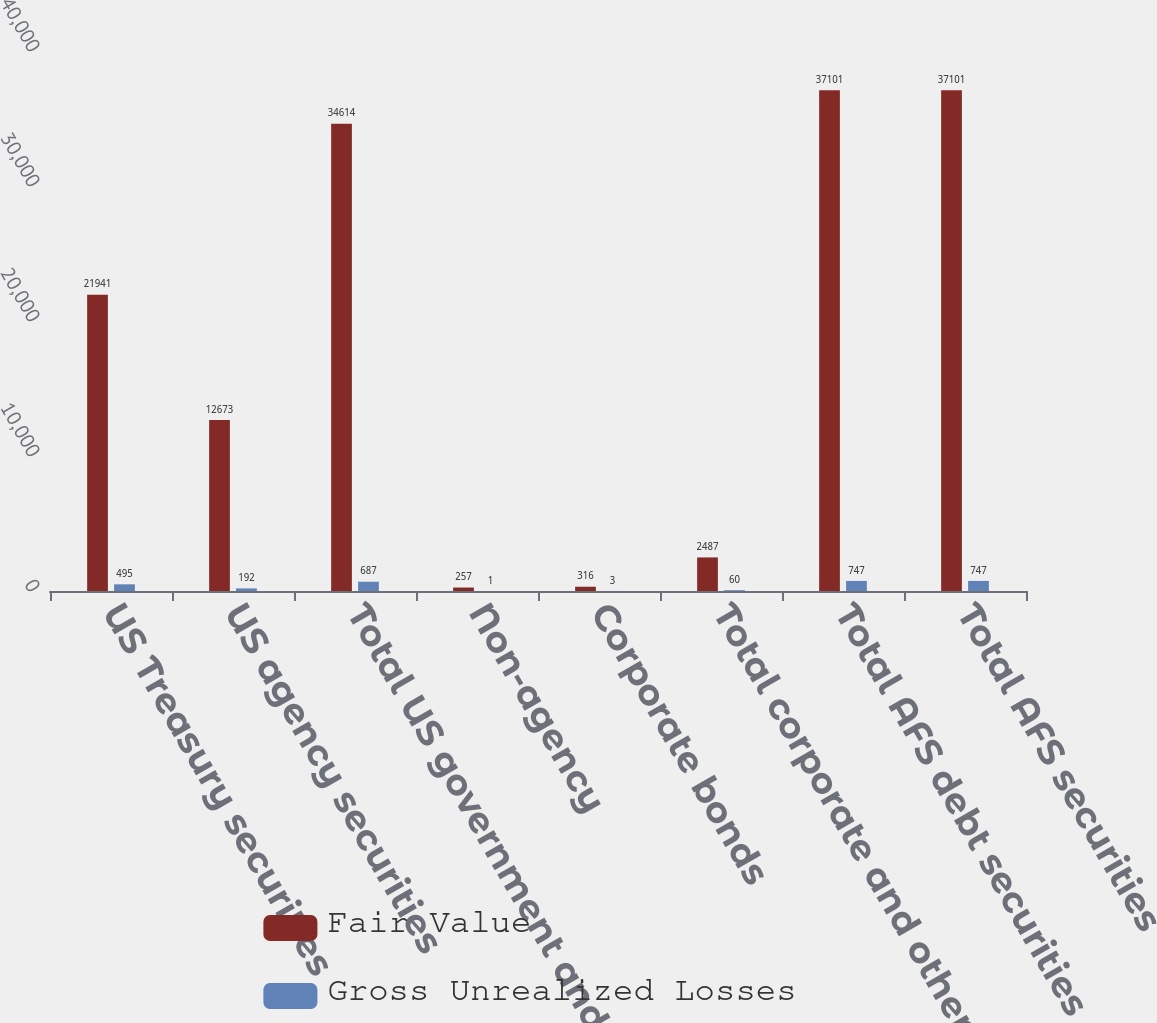Convert chart. <chart><loc_0><loc_0><loc_500><loc_500><stacked_bar_chart><ecel><fcel>US Treasury securities<fcel>US agency securities<fcel>Total US government and agency<fcel>Non-agency<fcel>Corporate bonds<fcel>Total corporate and other debt<fcel>Total AFS debt securities<fcel>Total AFS securities<nl><fcel>Fair Value<fcel>21941<fcel>12673<fcel>34614<fcel>257<fcel>316<fcel>2487<fcel>37101<fcel>37101<nl><fcel>Gross Unrealized Losses<fcel>495<fcel>192<fcel>687<fcel>1<fcel>3<fcel>60<fcel>747<fcel>747<nl></chart> 